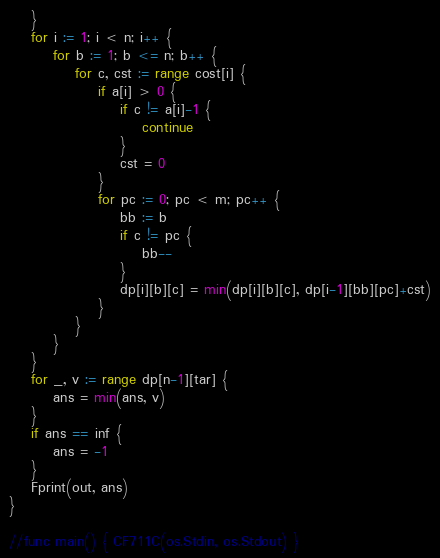<code> <loc_0><loc_0><loc_500><loc_500><_Go_>	}
	for i := 1; i < n; i++ {
		for b := 1; b <= n; b++ {
			for c, cst := range cost[i] {
				if a[i] > 0 {
					if c != a[i]-1 {
						continue
					}
					cst = 0
				}
				for pc := 0; pc < m; pc++ {
					bb := b
					if c != pc {
						bb--
					}
					dp[i][b][c] = min(dp[i][b][c], dp[i-1][bb][pc]+cst)
				}
			}
		}
	}
	for _, v := range dp[n-1][tar] {
		ans = min(ans, v)
	}
	if ans == inf {
		ans = -1
	}
	Fprint(out, ans)
}

//func main() { CF711C(os.Stdin, os.Stdout) }
</code> 